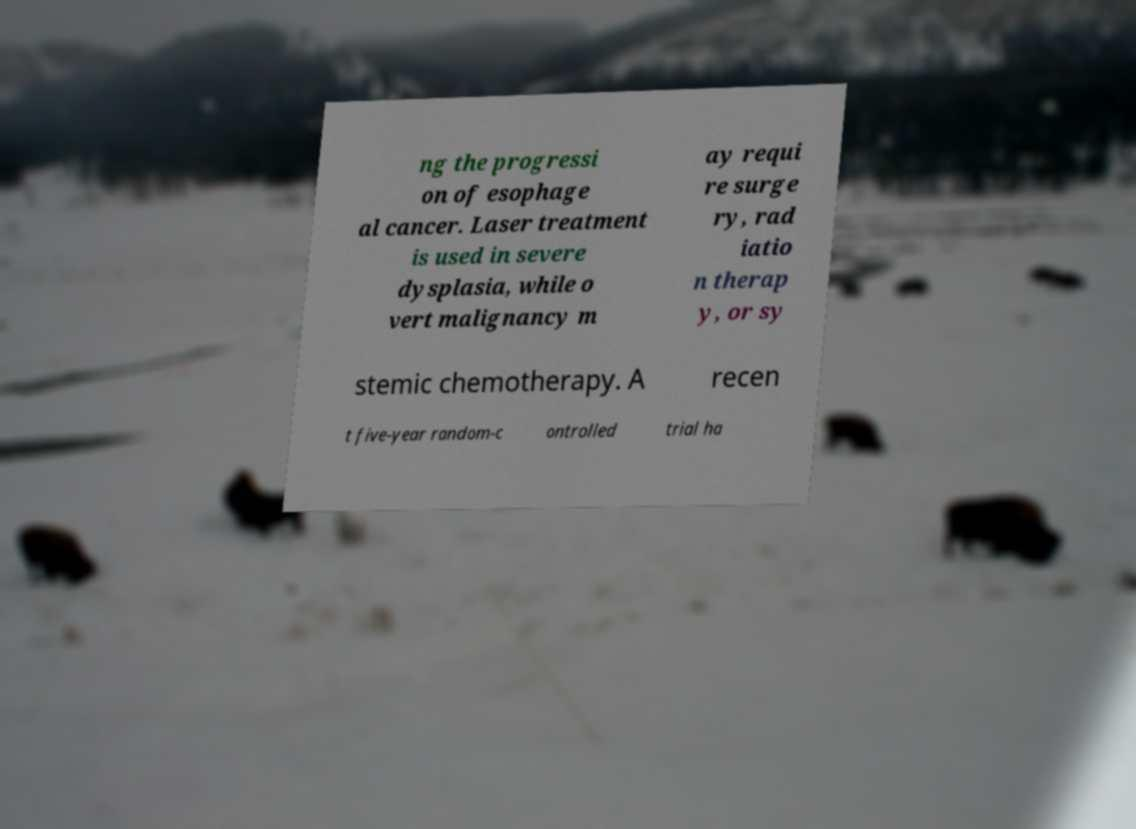Can you accurately transcribe the text from the provided image for me? ng the progressi on of esophage al cancer. Laser treatment is used in severe dysplasia, while o vert malignancy m ay requi re surge ry, rad iatio n therap y, or sy stemic chemotherapy. A recen t five-year random-c ontrolled trial ha 